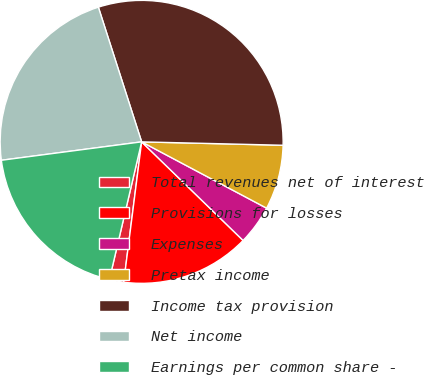<chart> <loc_0><loc_0><loc_500><loc_500><pie_chart><fcel>Total revenues net of interest<fcel>Provisions for losses<fcel>Expenses<fcel>Pretax income<fcel>Income tax provision<fcel>Net income<fcel>Earnings per common share -<nl><fcel>1.64%<fcel>14.75%<fcel>4.51%<fcel>7.38%<fcel>30.33%<fcel>22.13%<fcel>19.26%<nl></chart> 